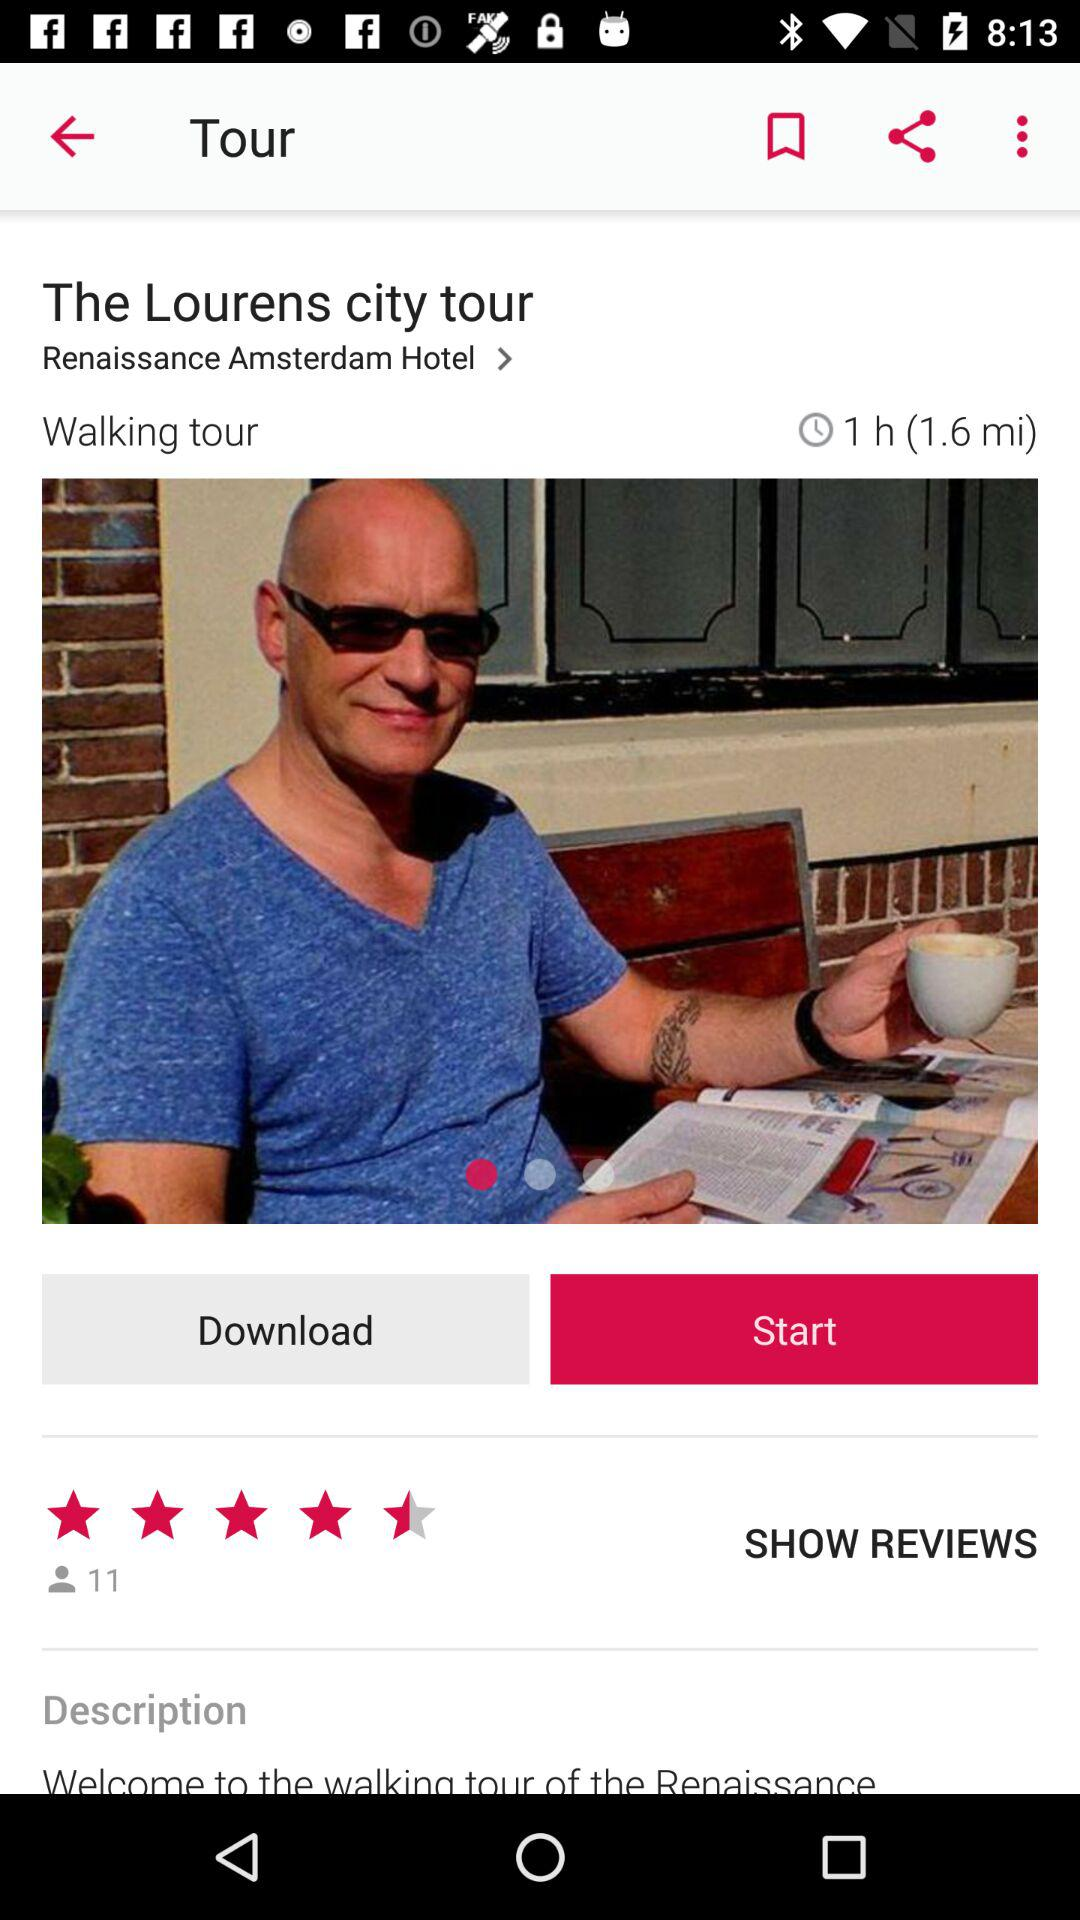How many people have reviewed the tour?
Answer the question using a single word or phrase. 11 